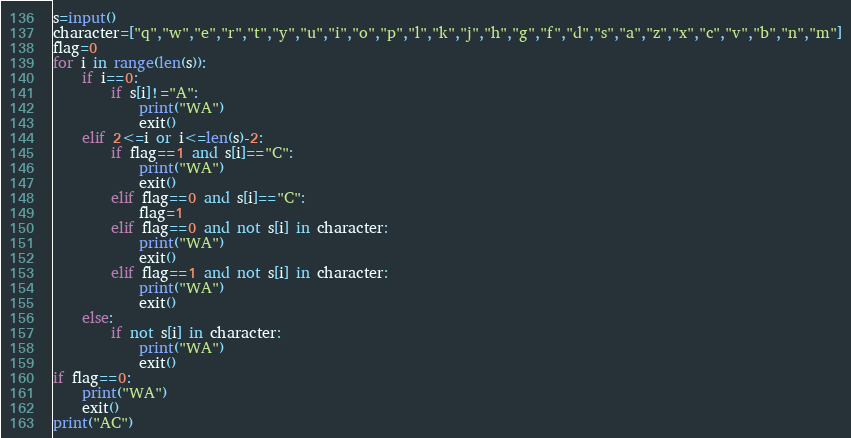<code> <loc_0><loc_0><loc_500><loc_500><_Python_>s=input()
character=["q","w","e","r","t","y","u","i","o","p","l","k","j","h","g","f","d","s","a","z","x","c","v","b","n","m"]
flag=0
for i in range(len(s)):
    if i==0:
        if s[i]!="A":
            print("WA")
            exit()
    elif 2<=i or i<=len(s)-2:
        if flag==1 and s[i]=="C":
            print("WA")
            exit()
        elif flag==0 and s[i]=="C":
            flag=1
        elif flag==0 and not s[i] in character:
            print("WA")
            exit()
        elif flag==1 and not s[i] in character:
            print("WA")
            exit()
    else:
        if not s[i] in character:
            print("WA")
            exit()
if flag==0:
    print("WA")
    exit()
print("AC")
</code> 